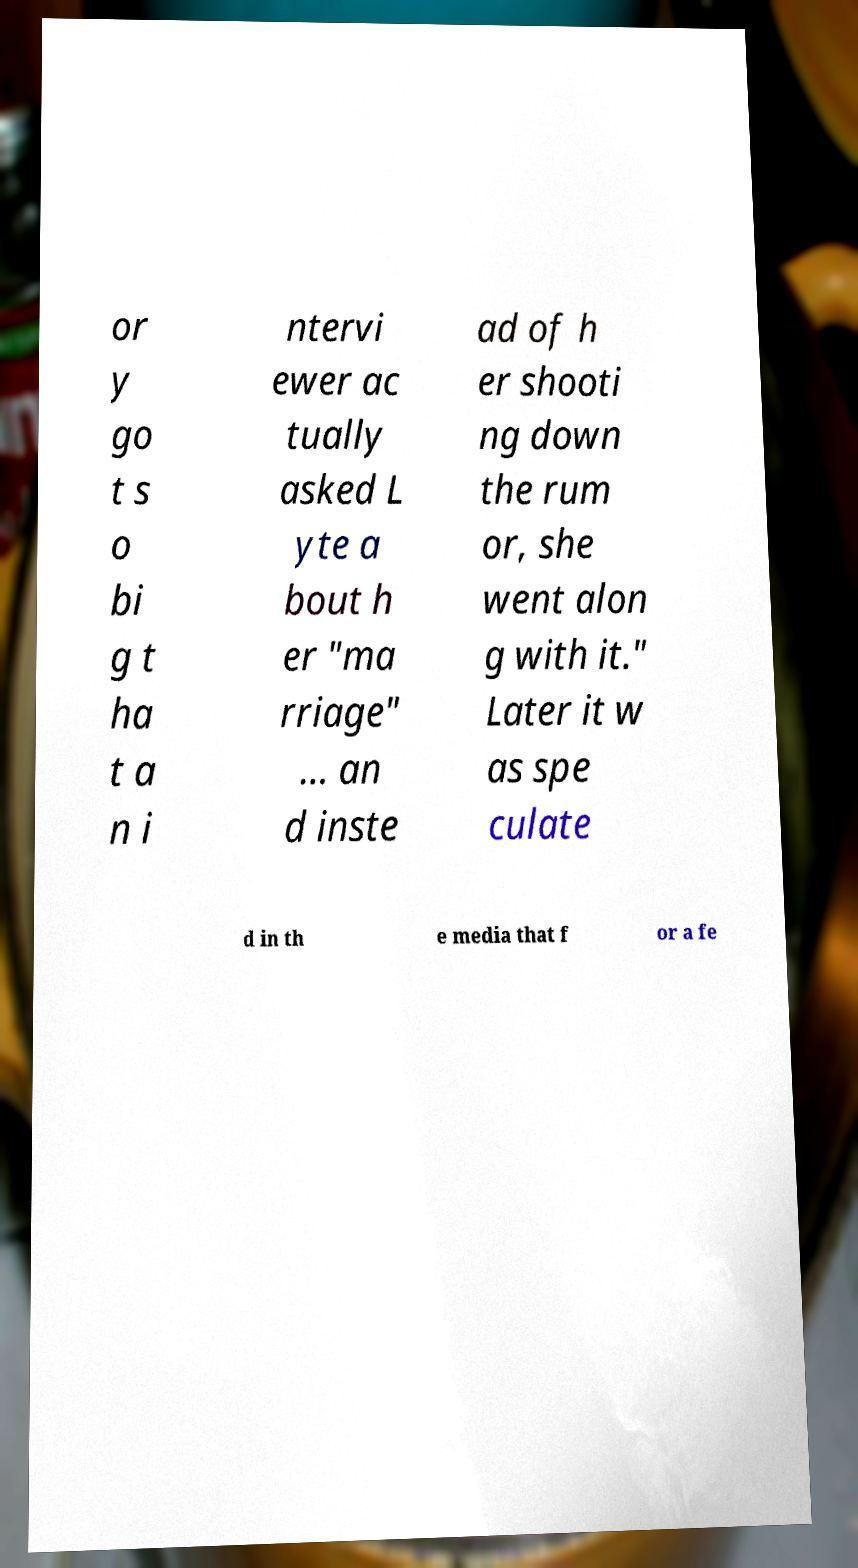For documentation purposes, I need the text within this image transcribed. Could you provide that? or y go t s o bi g t ha t a n i ntervi ewer ac tually asked L yte a bout h er "ma rriage" ... an d inste ad of h er shooti ng down the rum or, she went alon g with it." Later it w as spe culate d in th e media that f or a fe 